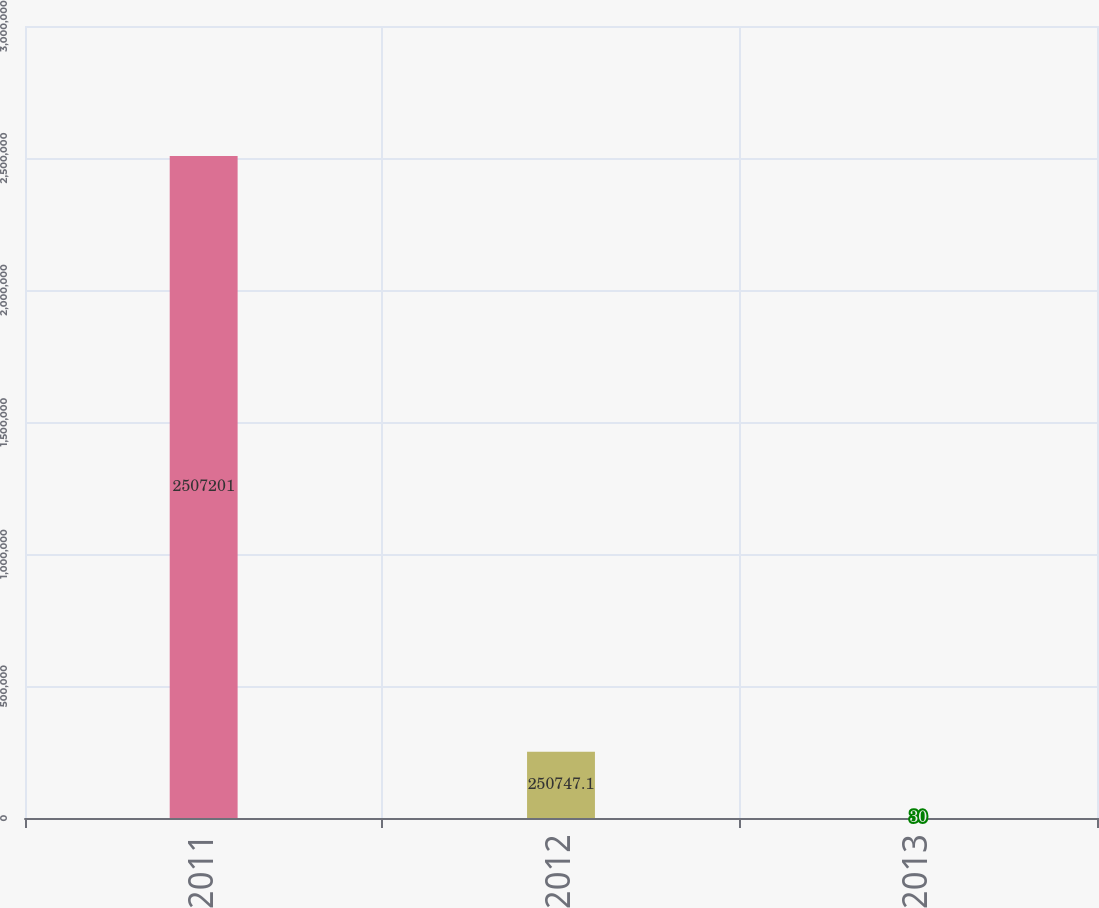Convert chart. <chart><loc_0><loc_0><loc_500><loc_500><bar_chart><fcel>2011<fcel>2012<fcel>2013<nl><fcel>2.5072e+06<fcel>250747<fcel>30<nl></chart> 